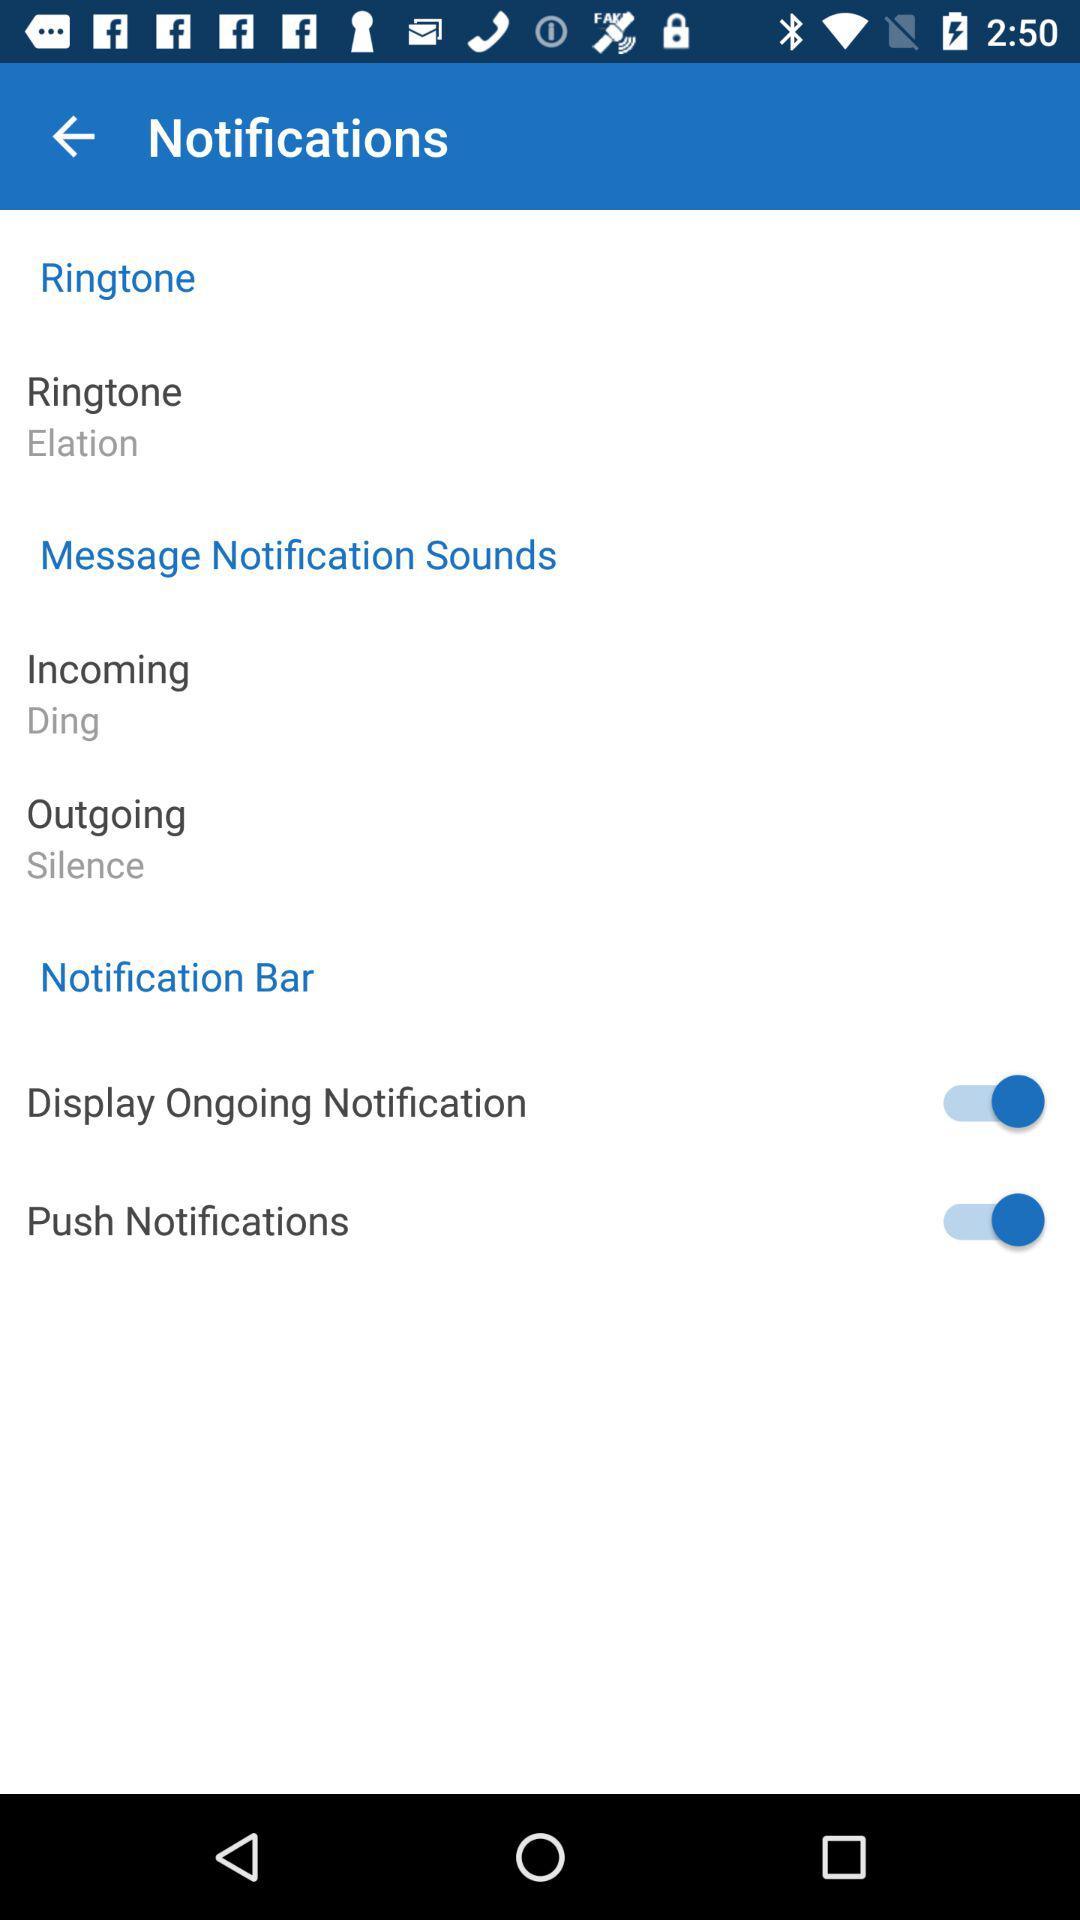What is the selected ringtone? The selected ringtone is "Elation". 